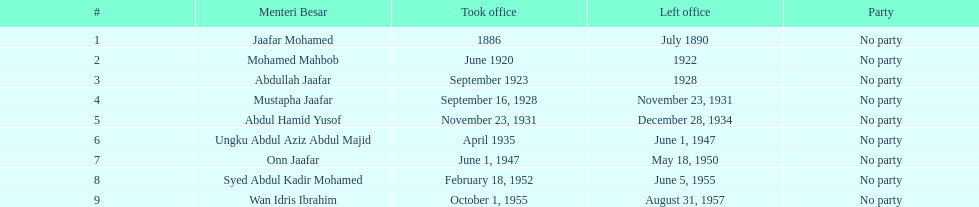Who was in office after mustapha jaafar Abdul Hamid Yusof. 